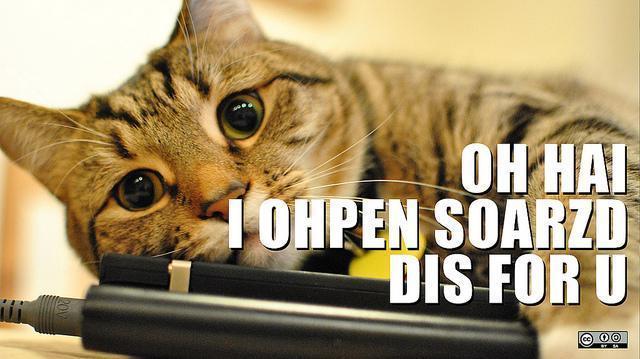How many of these people are women?
Give a very brief answer. 0. 